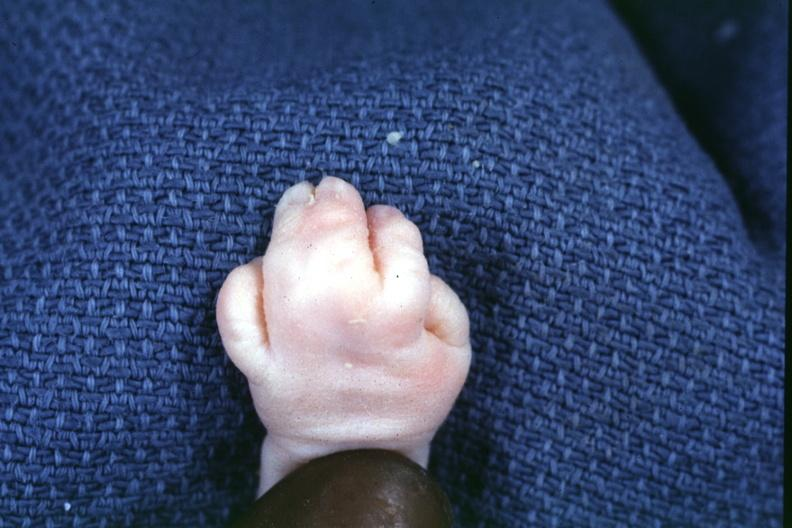what is present?
Answer the question using a single word or phrase. Hand 